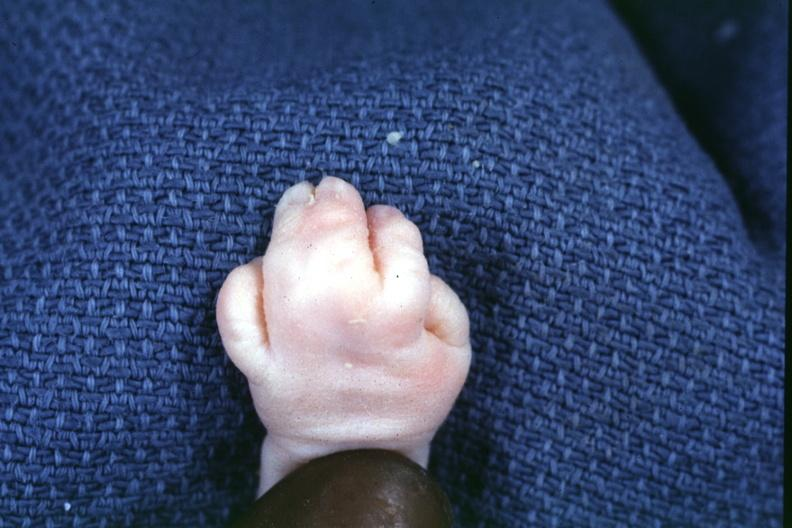what is present?
Answer the question using a single word or phrase. Hand 